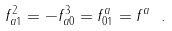<formula> <loc_0><loc_0><loc_500><loc_500>f ^ { 2 } _ { a 1 } = - f ^ { 3 } _ { a 0 } = f ^ { a } _ { 0 1 } = f ^ { a } \ .</formula> 